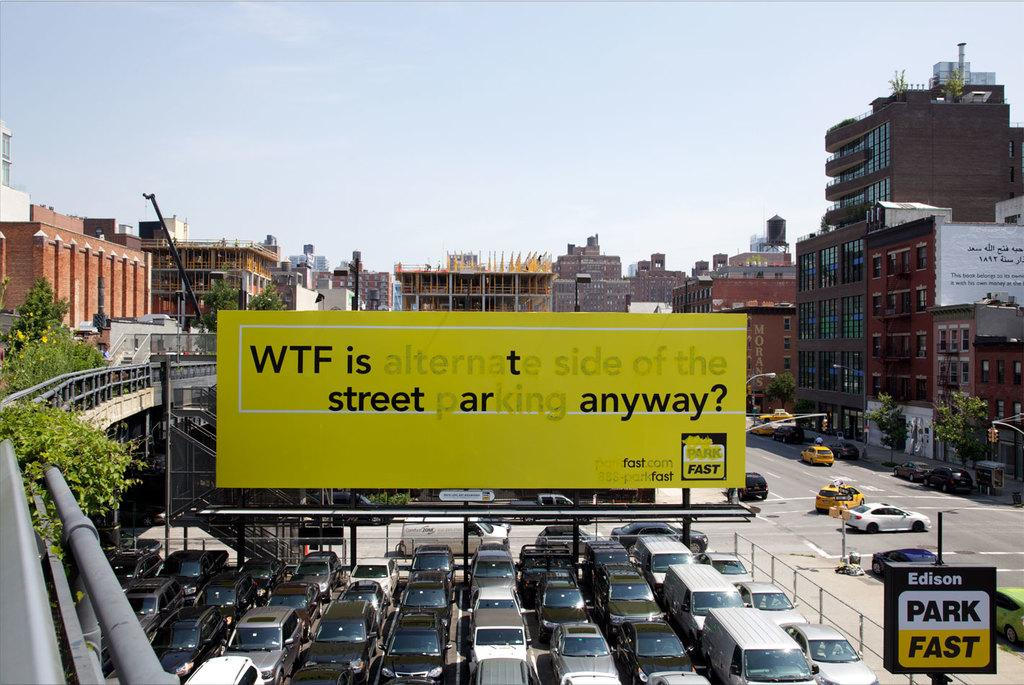<image>
Write a terse but informative summary of the picture. A large yellow sign that says WTF is alternate side of the street parking anyway. 